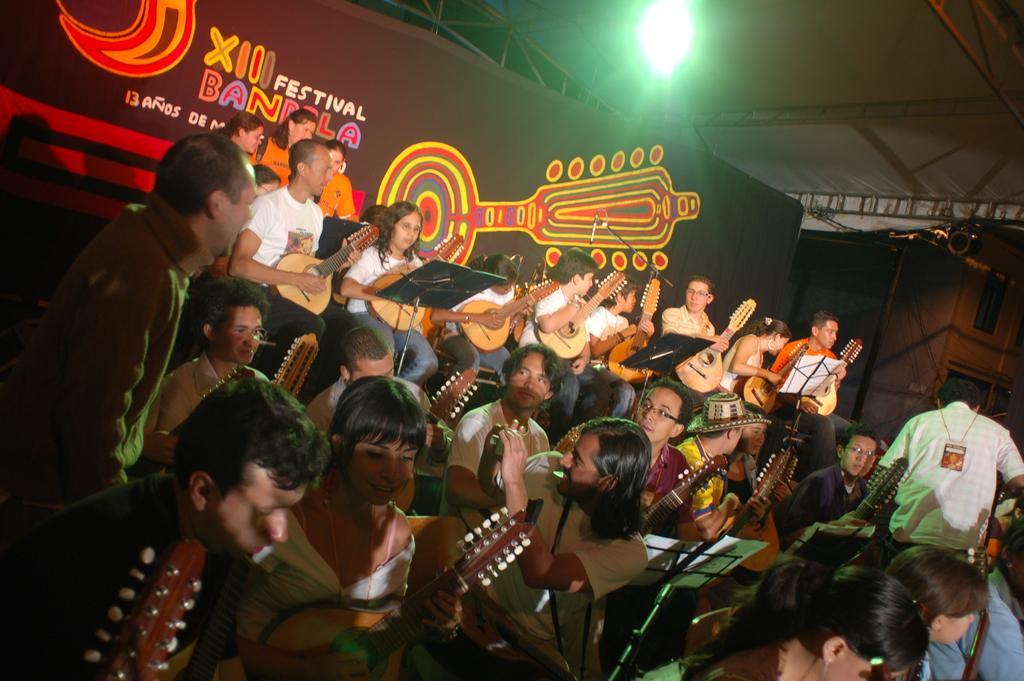Please provide a concise description of this image. In the image few people are standing and sitting and holding some musical instruments. Behind them there is a banner. At the top of the image there is a roof and light. 